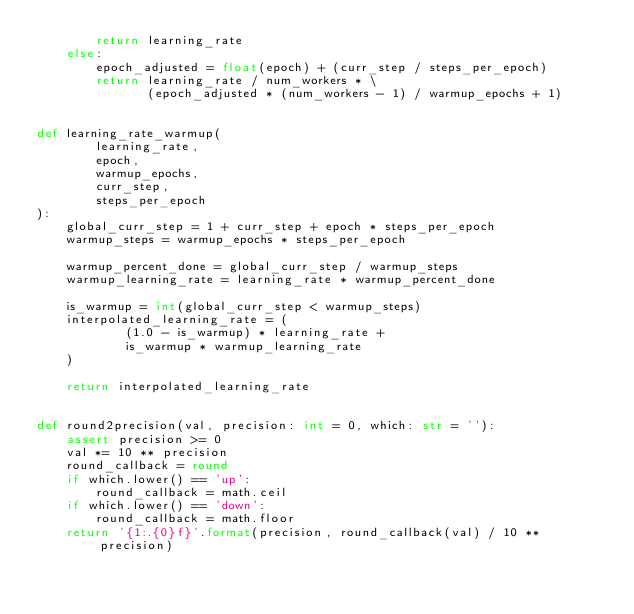<code> <loc_0><loc_0><loc_500><loc_500><_Python_>        return learning_rate
    else:
        epoch_adjusted = float(epoch) + (curr_step / steps_per_epoch)
        return learning_rate / num_workers * \
               (epoch_adjusted * (num_workers - 1) / warmup_epochs + 1)


def learning_rate_warmup(
        learning_rate,
        epoch,
        warmup_epochs,
        curr_step,
        steps_per_epoch
):
    global_curr_step = 1 + curr_step + epoch * steps_per_epoch
    warmup_steps = warmup_epochs * steps_per_epoch

    warmup_percent_done = global_curr_step / warmup_steps
    warmup_learning_rate = learning_rate * warmup_percent_done

    is_warmup = int(global_curr_step < warmup_steps)
    interpolated_learning_rate = (
            (1.0 - is_warmup) * learning_rate +
            is_warmup * warmup_learning_rate
    )

    return interpolated_learning_rate


def round2precision(val, precision: int = 0, which: str = ''):
    assert precision >= 0
    val *= 10 ** precision
    round_callback = round
    if which.lower() == 'up':
        round_callback = math.ceil
    if which.lower() == 'down':
        round_callback = math.floor
    return '{1:.{0}f}'.format(precision, round_callback(val) / 10 ** precision)
</code> 